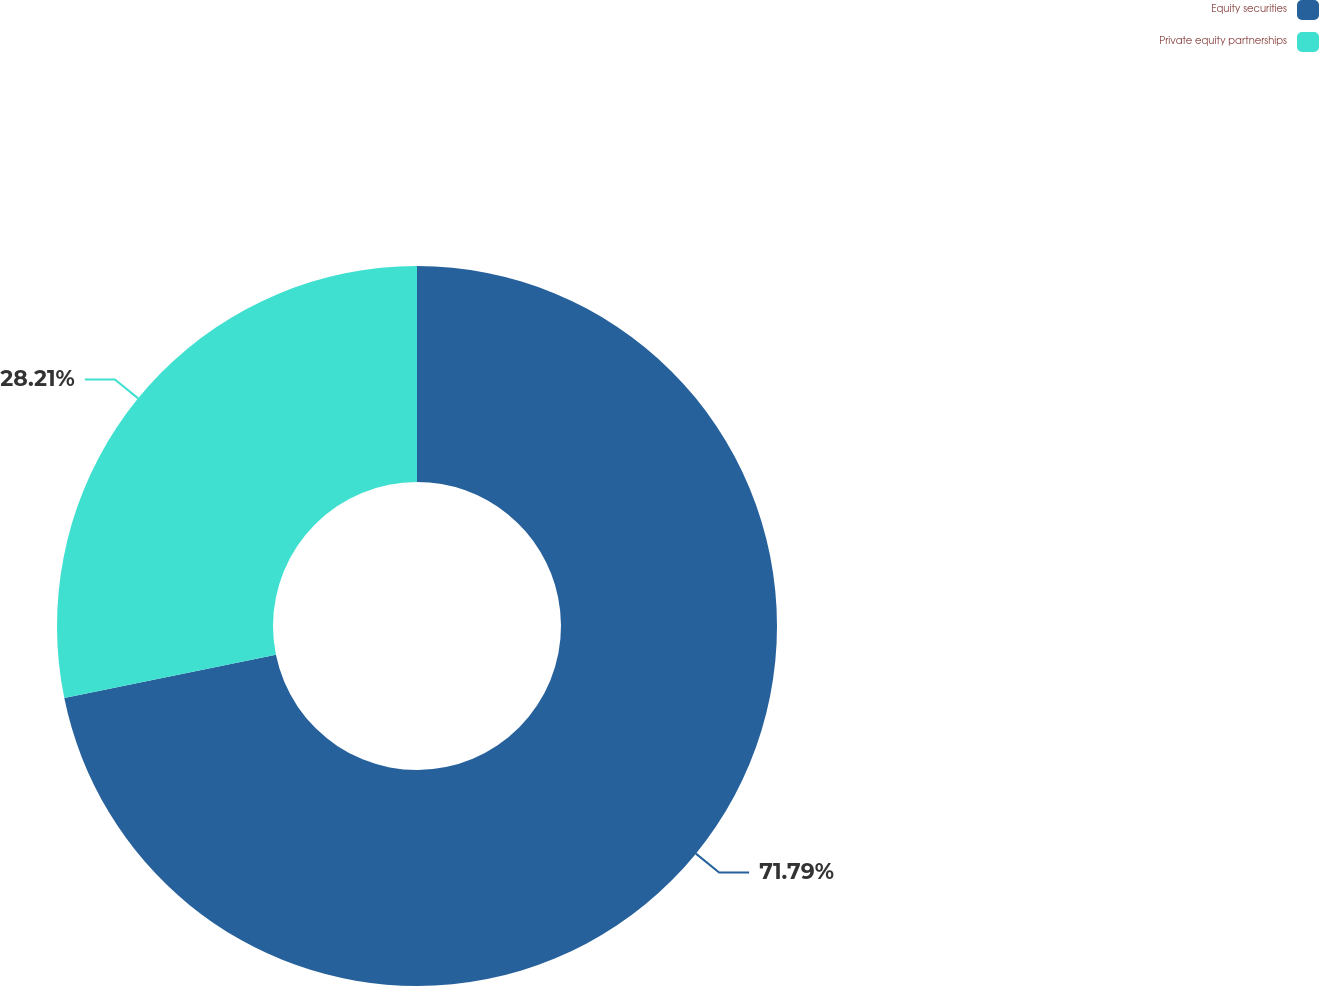Convert chart. <chart><loc_0><loc_0><loc_500><loc_500><pie_chart><fcel>Equity securities<fcel>Private equity partnerships<nl><fcel>71.79%<fcel>28.21%<nl></chart> 